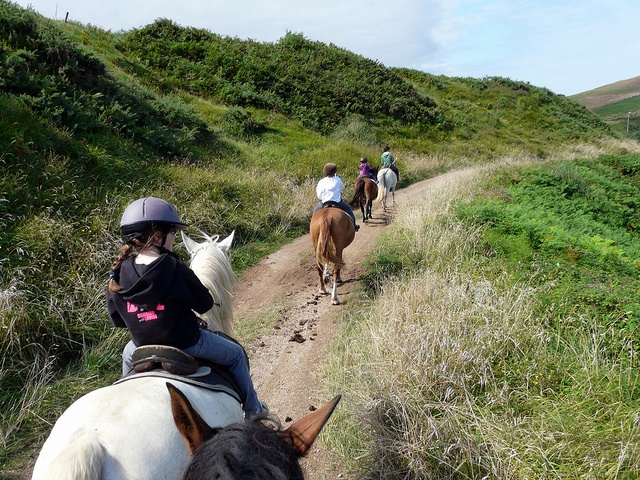Describe the objects in this image and their specific colors. I can see horse in darkgreen, white, darkgray, and gray tones, people in darkgreen, black, navy, gray, and lightgray tones, horse in darkgreen, black, gray, and maroon tones, horse in darkgreen, maroon, gray, black, and tan tones, and people in darkgreen, white, black, gray, and darkgray tones in this image. 